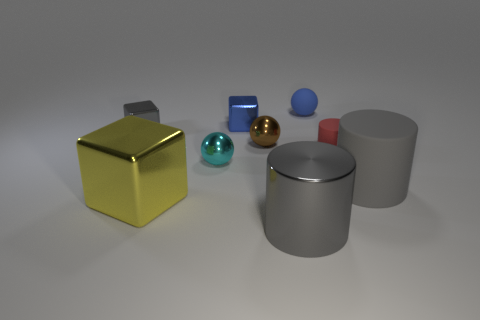Is the large matte cylinder the same color as the metal cylinder?
Provide a succinct answer. Yes. Is there anything else that is the same color as the tiny matte ball?
Offer a terse response. Yes. Does the gray shiny object behind the yellow shiny object have the same size as the big yellow thing?
Your response must be concise. No. There is a metal thing that is left of the cube that is in front of the small brown ball; what is its shape?
Your response must be concise. Cube. What number of small objects are either brown things or blue objects?
Your answer should be very brief. 3. What number of large blue metal things are the same shape as the small red rubber object?
Your answer should be very brief. 0. Does the large gray shiny thing have the same shape as the large thing that is behind the big yellow metallic cube?
Offer a very short reply. Yes. There is a brown sphere; what number of tiny balls are in front of it?
Provide a short and direct response. 1. Are there any rubber cylinders of the same size as the brown sphere?
Offer a very short reply. Yes. There is a large gray thing that is in front of the yellow block; does it have the same shape as the blue shiny object?
Your response must be concise. No. 